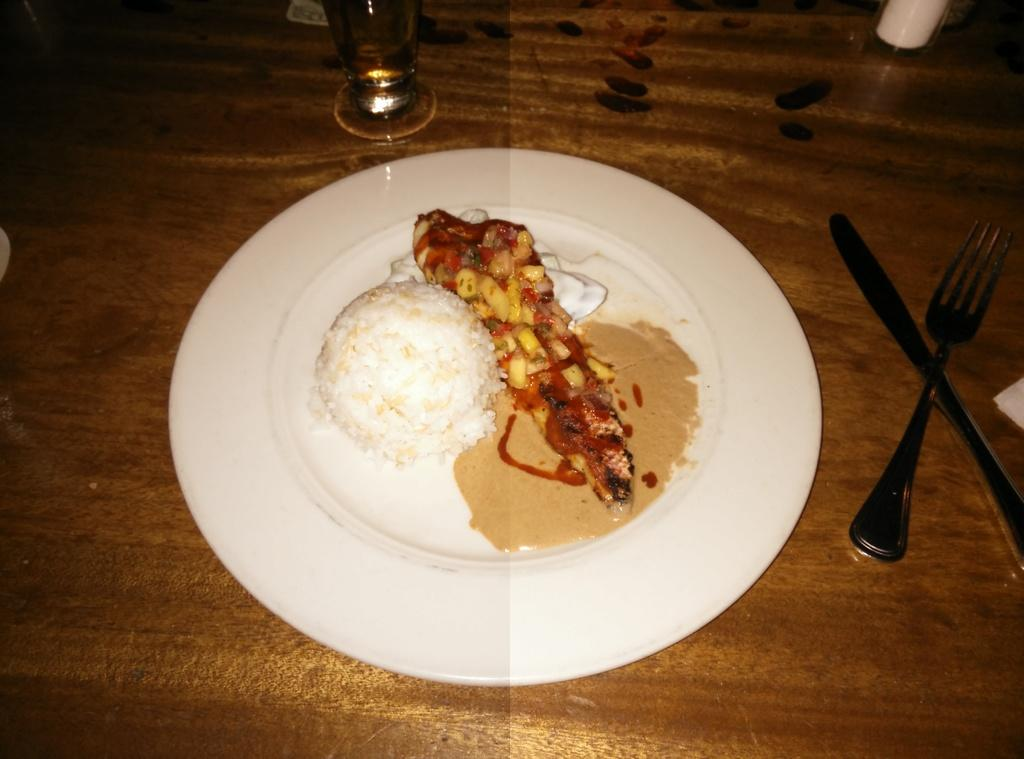What is on the white plate in the image? There is food on a white plate in the image. What utensils are present in the image? There is a fork and a knife in the image. What is the drinkware item in the image? There is a glass in the image. What type of surface are the items placed on? The items are placed on a wooden surface. Can you describe any other objects in the image? There are other objects in the image, but their specific details are not mentioned in the provided facts. What type of string is being used by the beggar in the image? There is no beggar or string present in the image. How does the trip affect the arrangement of the items in the image? There is no trip mentioned in the image, so it cannot affect the arrangement of the items. 